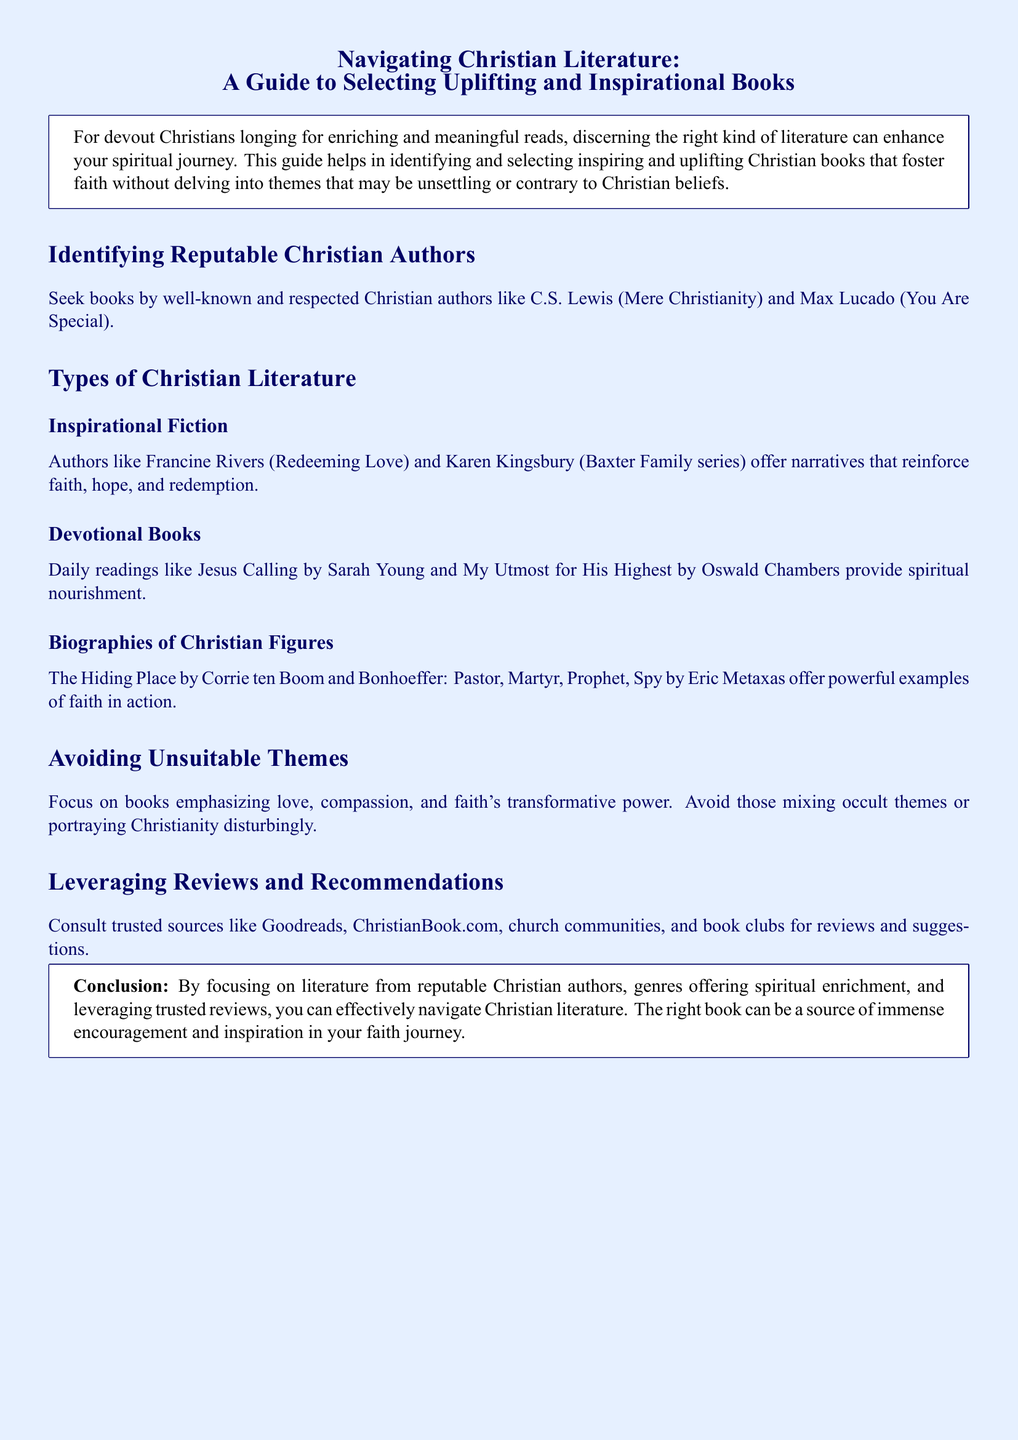What is the main purpose of the guide? The guide helps in identifying and selecting inspiring and uplifting Christian books that foster faith without delving into themes that may be unsettling or contrary to Christian beliefs.
Answer: To enhance spiritual journey Who is the author of "Mere Christianity"? "Mere Christianity" is written by C.S. Lewis, who is mentioned as a well-known and respected Christian author.
Answer: C.S. Lewis What genre does "Redeeming Love" belong to? "Redeeming Love" is categorized under Inspirational Fiction, as it offers narratives that reinforce faith, hope, and redemption.
Answer: Inspirational Fiction What type of literature provides daily spiritual nourishment? The document states that devotional books provide daily spiritual nourishment.
Answer: Devotional Books Which sources can be consulted for reviews and suggestions? Trusted sources include Goodreads, ChristianBook.com, church communities, and book clubs, as mentioned in the section about leveraging reviews.
Answer: Goodreads, ChristianBook.com What should be avoided when selecting Christian literature? The document advises to avoid books mixing occult themes or portraying Christianity disturbingly.
Answer: Unsuitable themes Name one author of a biography mentioned in the guide. Corrie ten Boom is mentioned as the author of "The Hiding Place," which is a biography of a Christian figure.
Answer: Corrie ten Boom How does the guide conclude? The conclusion emphasizes focusing on reputable authors and genres that offer spiritual enrichment along with leveraging trusted reviews.
Answer: Immense encouragement and inspiration What is the title of a devotional book listed in the document? "Jesus Calling" by Sarah Young is mentioned as a devotional book providing spiritual nourishment.
Answer: Jesus Calling 